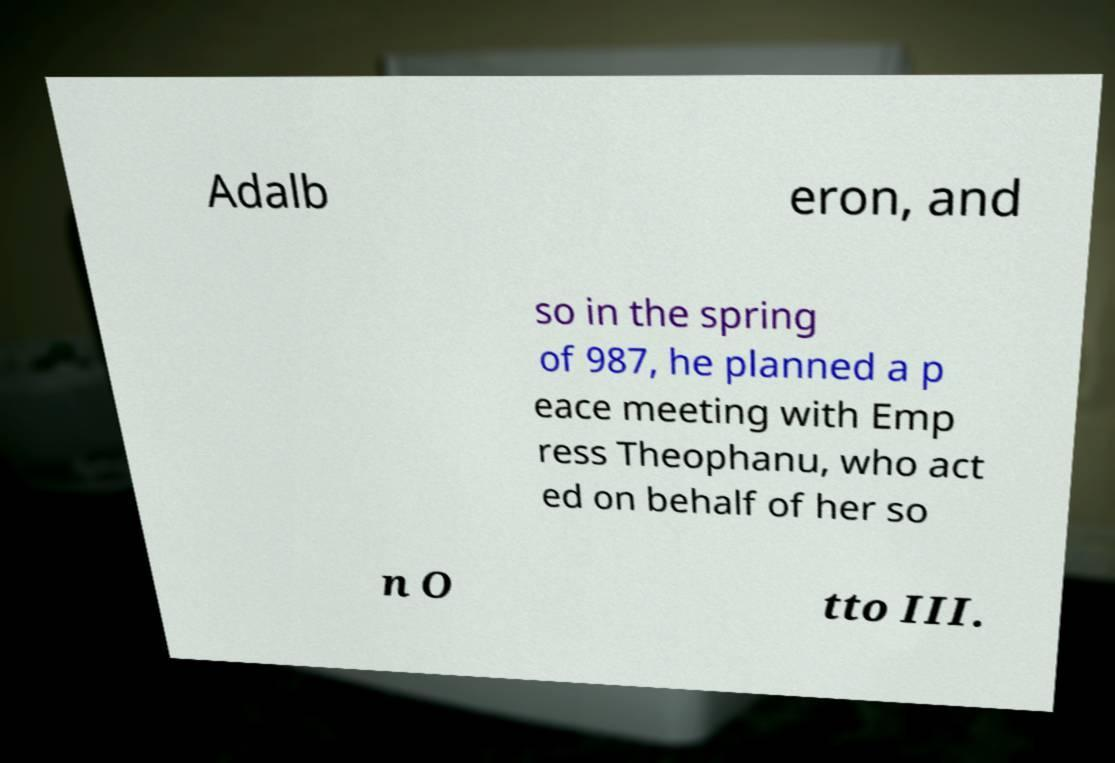For documentation purposes, I need the text within this image transcribed. Could you provide that? Adalb eron, and so in the spring of 987, he planned a p eace meeting with Emp ress Theophanu, who act ed on behalf of her so n O tto III. 